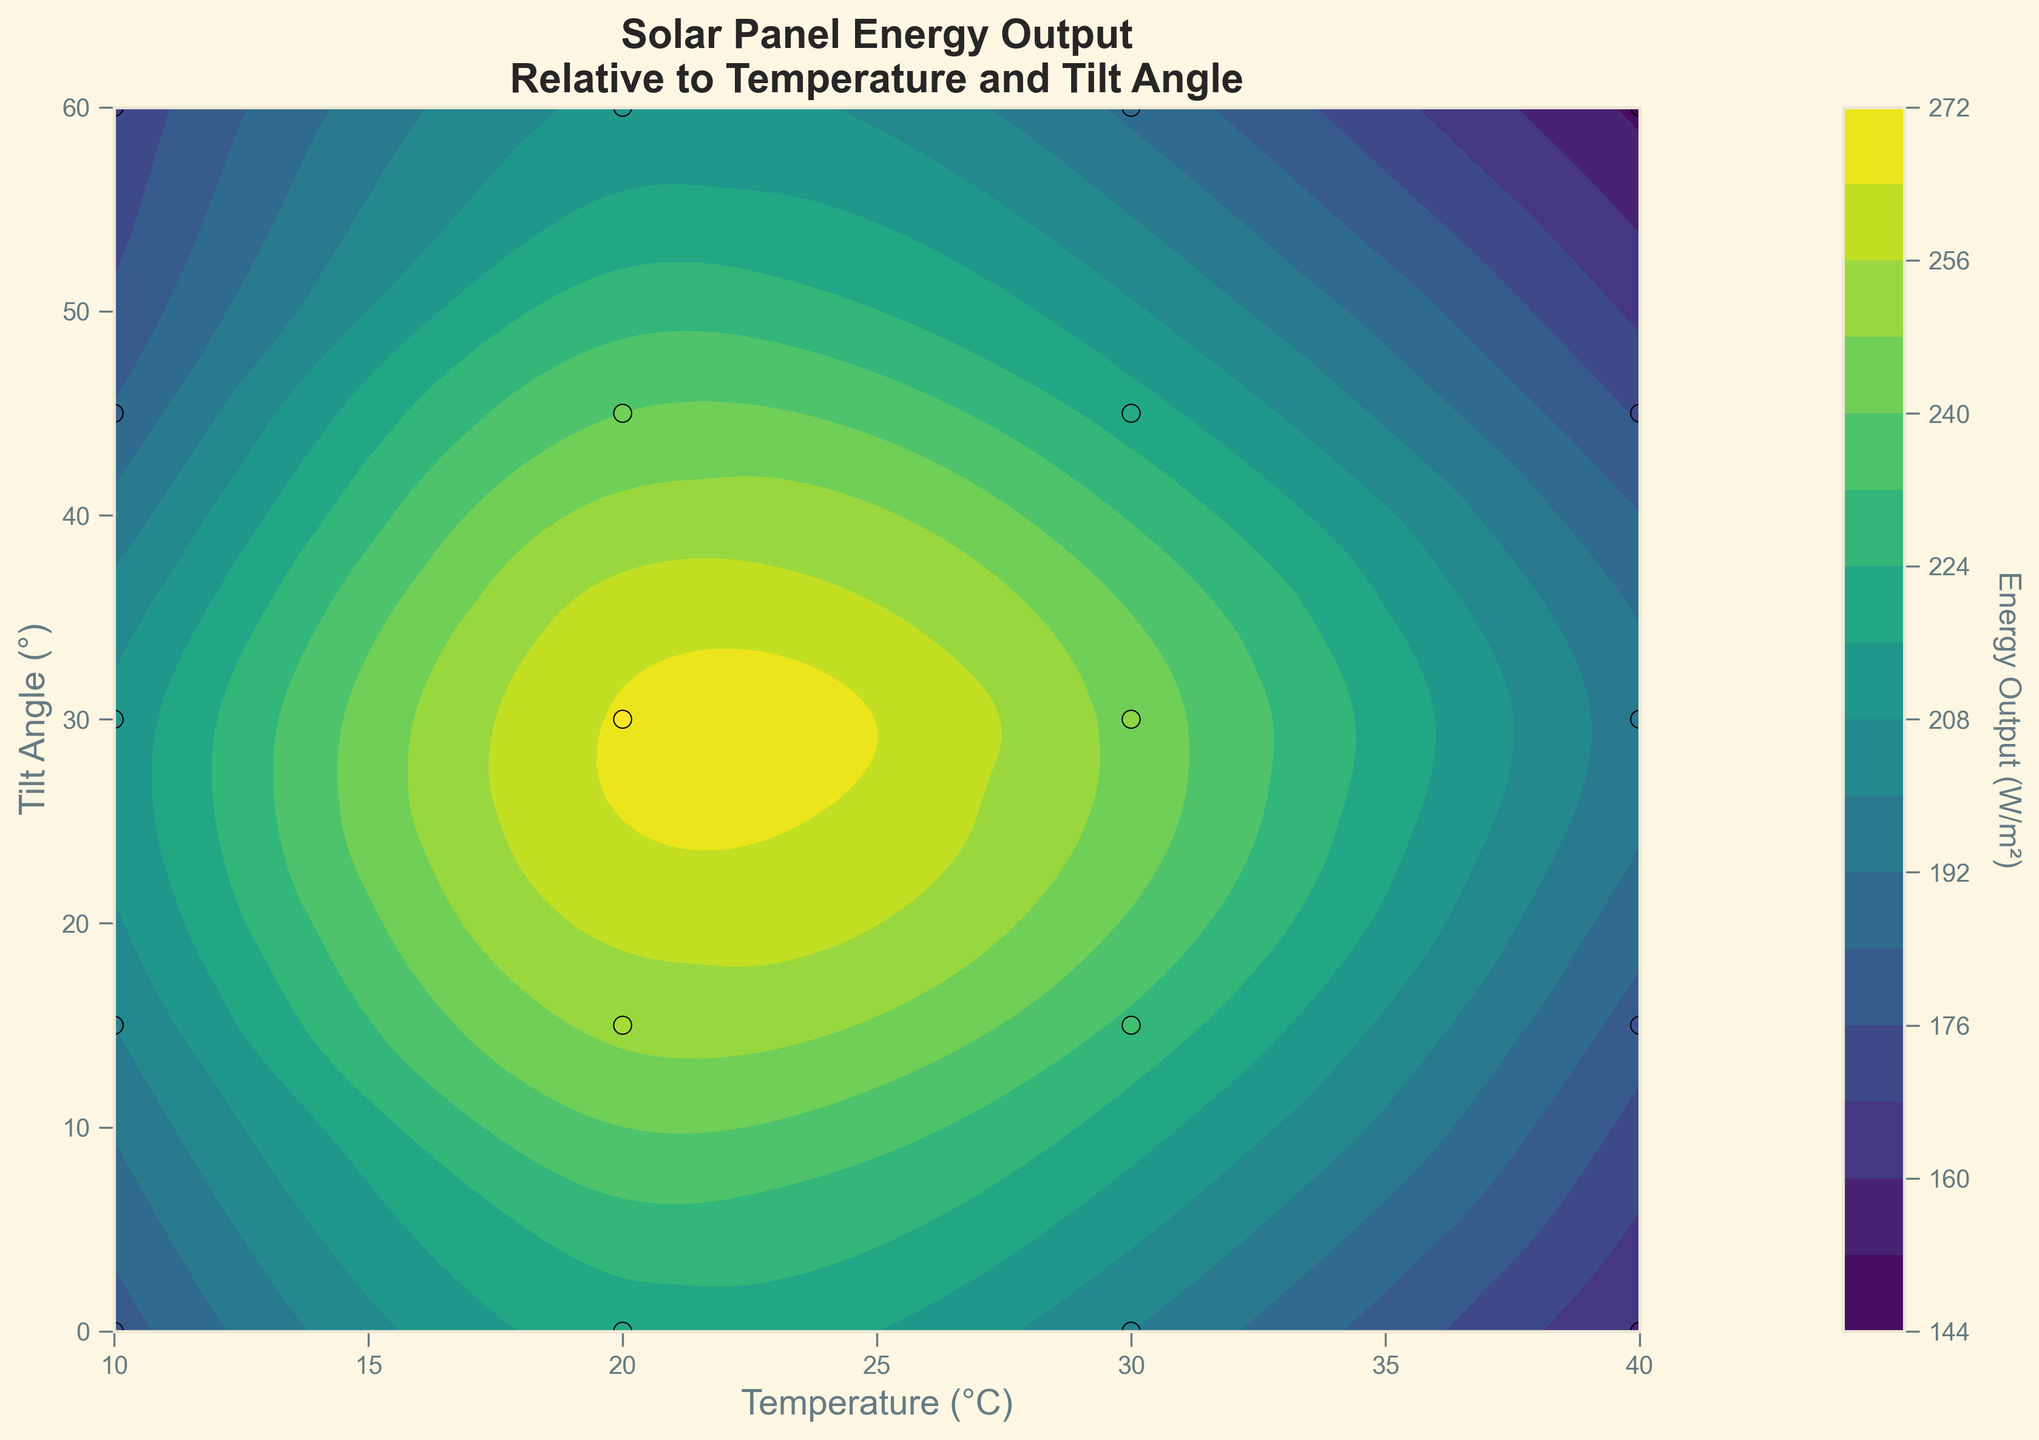What is the main title of the plot? The main title is located at the top of the plot. It reads "Solar Panel Energy Output\nRelative to Temperature and Tilt Angle."
Answer: Solar Panel Energy Output\nRelative to Temperature and Tilt Angle What do the x-axis and y-axis represent? The x-axis represents the ambient temperature in degrees Celsius (°C), and the y-axis represents the tilt angle in degrees (°). This is indicated by the axis labels.
Answer: Ambient Temperature (°C) and Tilt Angle (°) How many gradient levels are used in the contour plot? By examining the plot, one can count the number of color gradients present, which are often indicated by multiple shades. Additionally, the figure includes a color bar that gives a good indication of the gradient levels.
Answer: 15 Which tilt angle yields the highest energy output at 20°C? By focusing on the contour plot area where the temperature is 20°C, we notice the highest color intensity (brightest part) or the closest value on the color bar. The brightest area corresponds to the highest energy output at the tilt angle around 30°.
Answer: 30° What is the range of energy output values? To find the range of energy output values, one needs to look at the color bar, which indicates the minimum and maximum values (W/m²) associated with the gradient. The minimum is around 150 W/m² and the maximum is around 265 W/m².
Answer: 150 W/m² to 265 W/m² At which temperatures and tilt angles do the data points appear concentrated? Observing the scatter points, which are marked by small circular dots on the plot, they are concentrated around temperatures 10°C to 30°C and tilt angles 0° to 60°.
Answer: 10°C to 30°C and 0° to 60° Compare the energy output at 10°C with tilt angles at 15° and 45°. Which one is higher? Focusing on the data points at 10°C, there are two points of interest at 15° (200 W/m²) and 45° (185 W/m²). Comparing these values, 200 W/m² is higher than 185 W/m².
Answer: 15° (200 W/m²) What is the trend in energy output as the temperature increases from 20°C to 40°C for a tilt angle of 30°? By examining the contour lines or the color gradient specifically at the 30° tilt angle section, one can notice that energy output values tend to decrease as the temperature increases from 20°C (265 W/m²) to 40°C (195 W/m²).
Answer: Decreasing What is the energy output at 30°C for a tilt angle of 0° compared to 20°C for the same tilt angle? The energy output at 30°C and 0° is 200 W/m², and at 20°C and 0° it is 220 W/m². A comparison shows 220 W/m² (at 20°C) is higher than 200 W/m² (at 30°C).
Answer: 20°C (220 W/m²) Does the energy output show a significant change with tilt angle at a constant temperature of 40°C? Focusing on the contour lines at 40°C, the color remains relatively consistent across different tilt angles (ranging from 150 W/m² to 195 W/m²), indicating that the energy output does not significantly change.
Answer: No significant change 